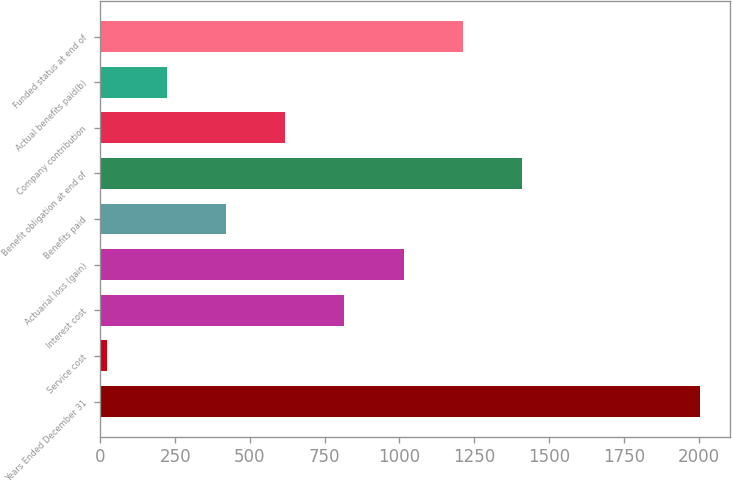<chart> <loc_0><loc_0><loc_500><loc_500><bar_chart><fcel>Years Ended December 31<fcel>Service cost<fcel>Interest cost<fcel>Actuarial loss (gain)<fcel>Benefits paid<fcel>Benefit obligation at end of<fcel>Company contribution<fcel>Actual benefits paid(b)<fcel>Funded status at end of<nl><fcel>2006<fcel>23<fcel>816.2<fcel>1014.5<fcel>419.6<fcel>1411.1<fcel>617.9<fcel>221.3<fcel>1212.8<nl></chart> 